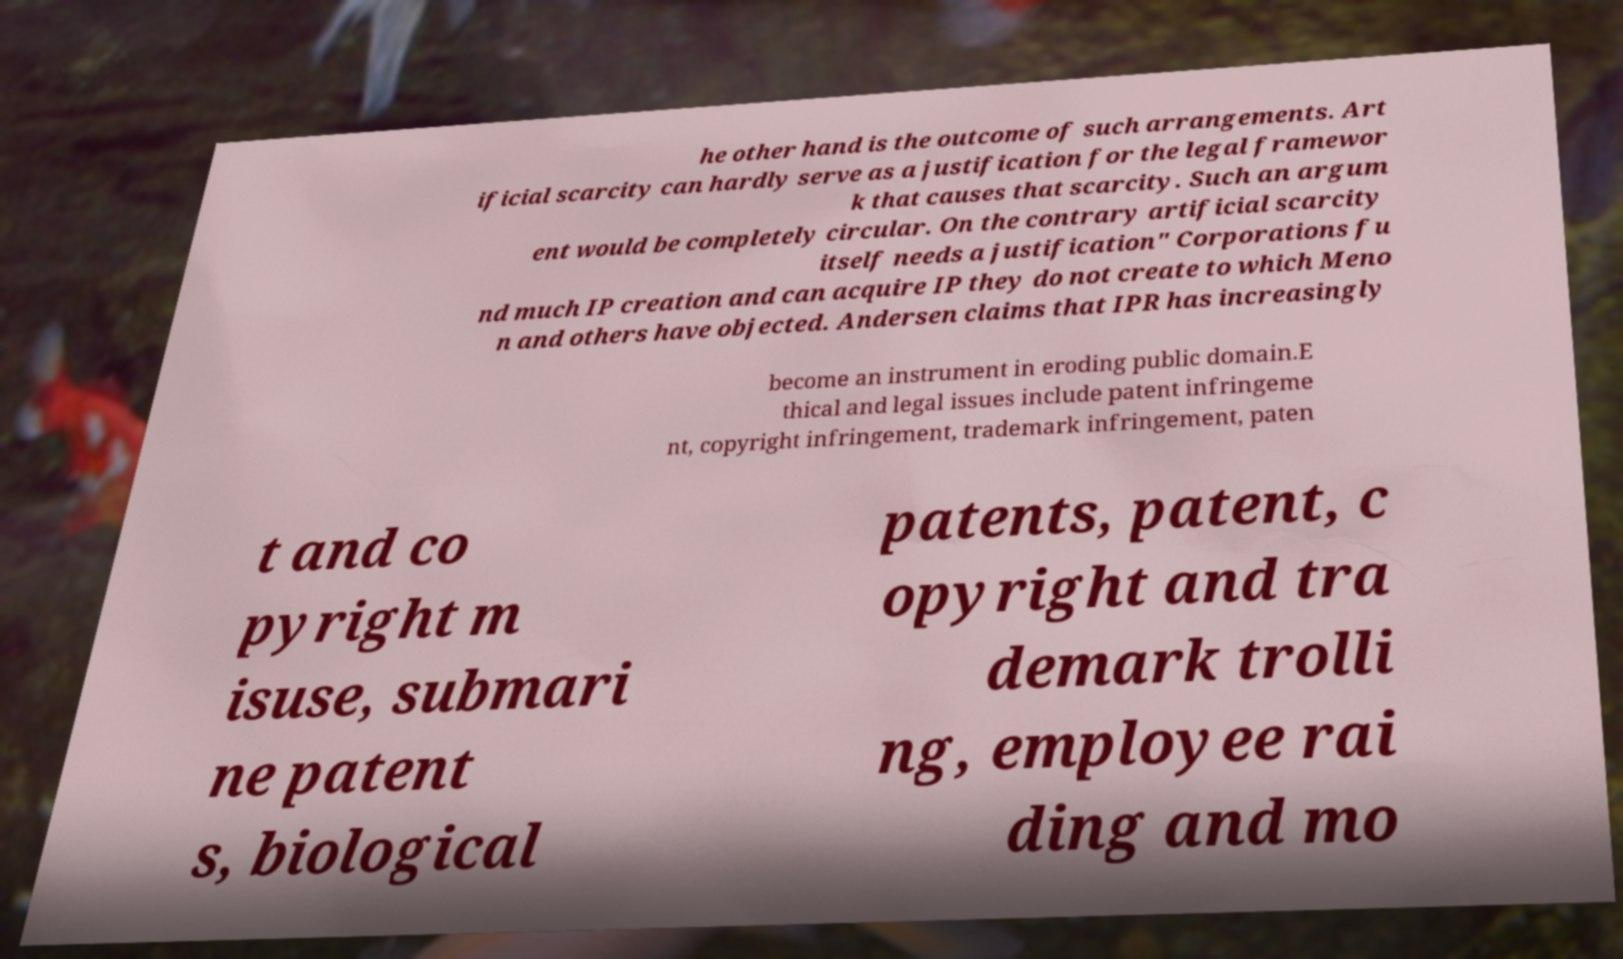Could you extract and type out the text from this image? he other hand is the outcome of such arrangements. Art ificial scarcity can hardly serve as a justification for the legal framewor k that causes that scarcity. Such an argum ent would be completely circular. On the contrary artificial scarcity itself needs a justification" Corporations fu nd much IP creation and can acquire IP they do not create to which Meno n and others have objected. Andersen claims that IPR has increasingly become an instrument in eroding public domain.E thical and legal issues include patent infringeme nt, copyright infringement, trademark infringement, paten t and co pyright m isuse, submari ne patent s, biological patents, patent, c opyright and tra demark trolli ng, employee rai ding and mo 